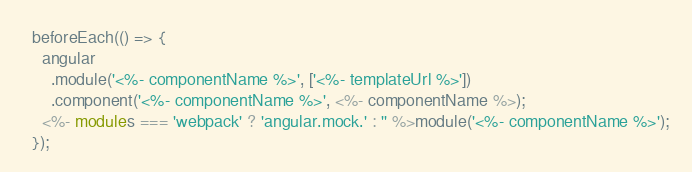Convert code to text. <code><loc_0><loc_0><loc_500><loc_500><_TypeScript_>  beforeEach(() => {
    angular
      .module('<%- componentName %>', ['<%- templateUrl %>'])
      .component('<%- componentName %>', <%- componentName %>);
    <%- modules === 'webpack' ? 'angular.mock.' : '' %>module('<%- componentName %>');
  });
</code> 